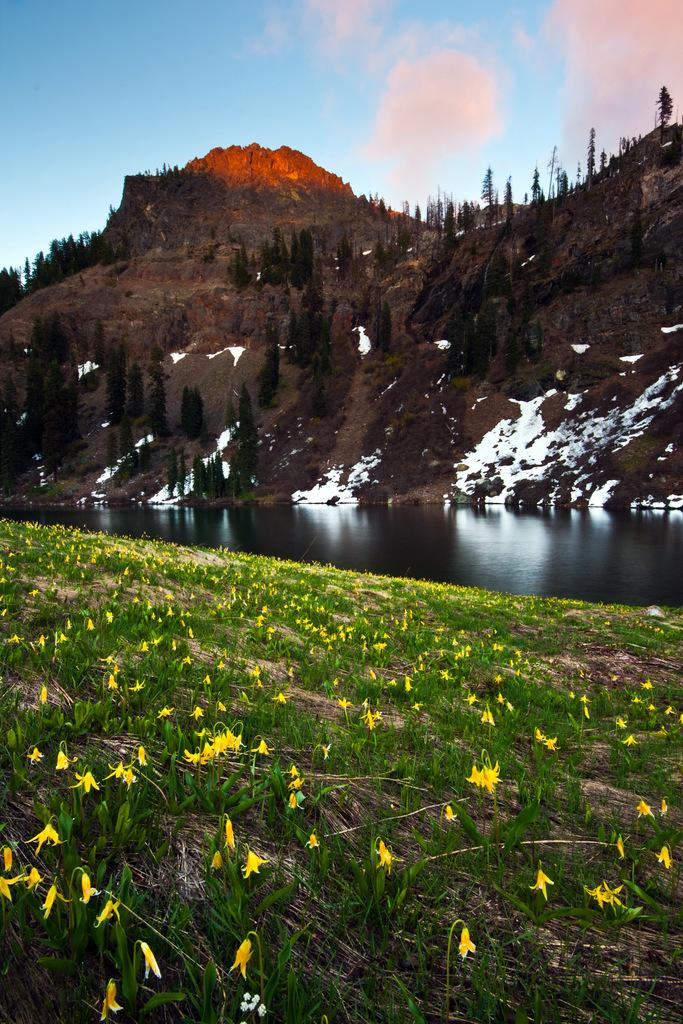What types of vegetation can be seen at the bottom of the image? There are plants and flowers at the bottom of the image. What is located in the middle of the image? There is water in the middle of the image. What natural features are visible at the top of the image? There are trees and hills at the top of the image. What can be seen in the sky in the image? There are clouds visible in the image. What part of the natural environment is visible in the image? The sky is visible in the image. How many passengers are visible in the bucket in the image? There is no bucket or passengers present in the image. What type of lock is used to secure the trees in the image? There is no lock present in the image, and trees are not secured. 